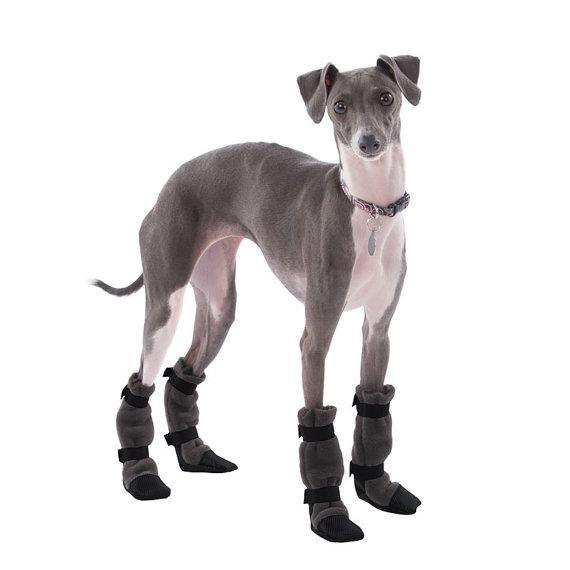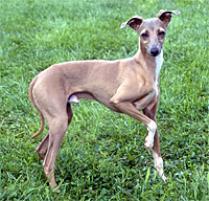The first image is the image on the left, the second image is the image on the right. Considering the images on both sides, is "All dog legs are visible and no dog is sitting or laying down." valid? Answer yes or no. Yes. 